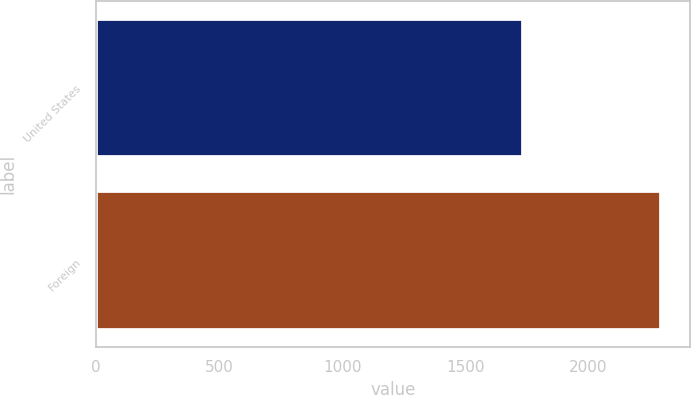Convert chart. <chart><loc_0><loc_0><loc_500><loc_500><bar_chart><fcel>United States<fcel>Foreign<nl><fcel>1736<fcel>2298<nl></chart> 